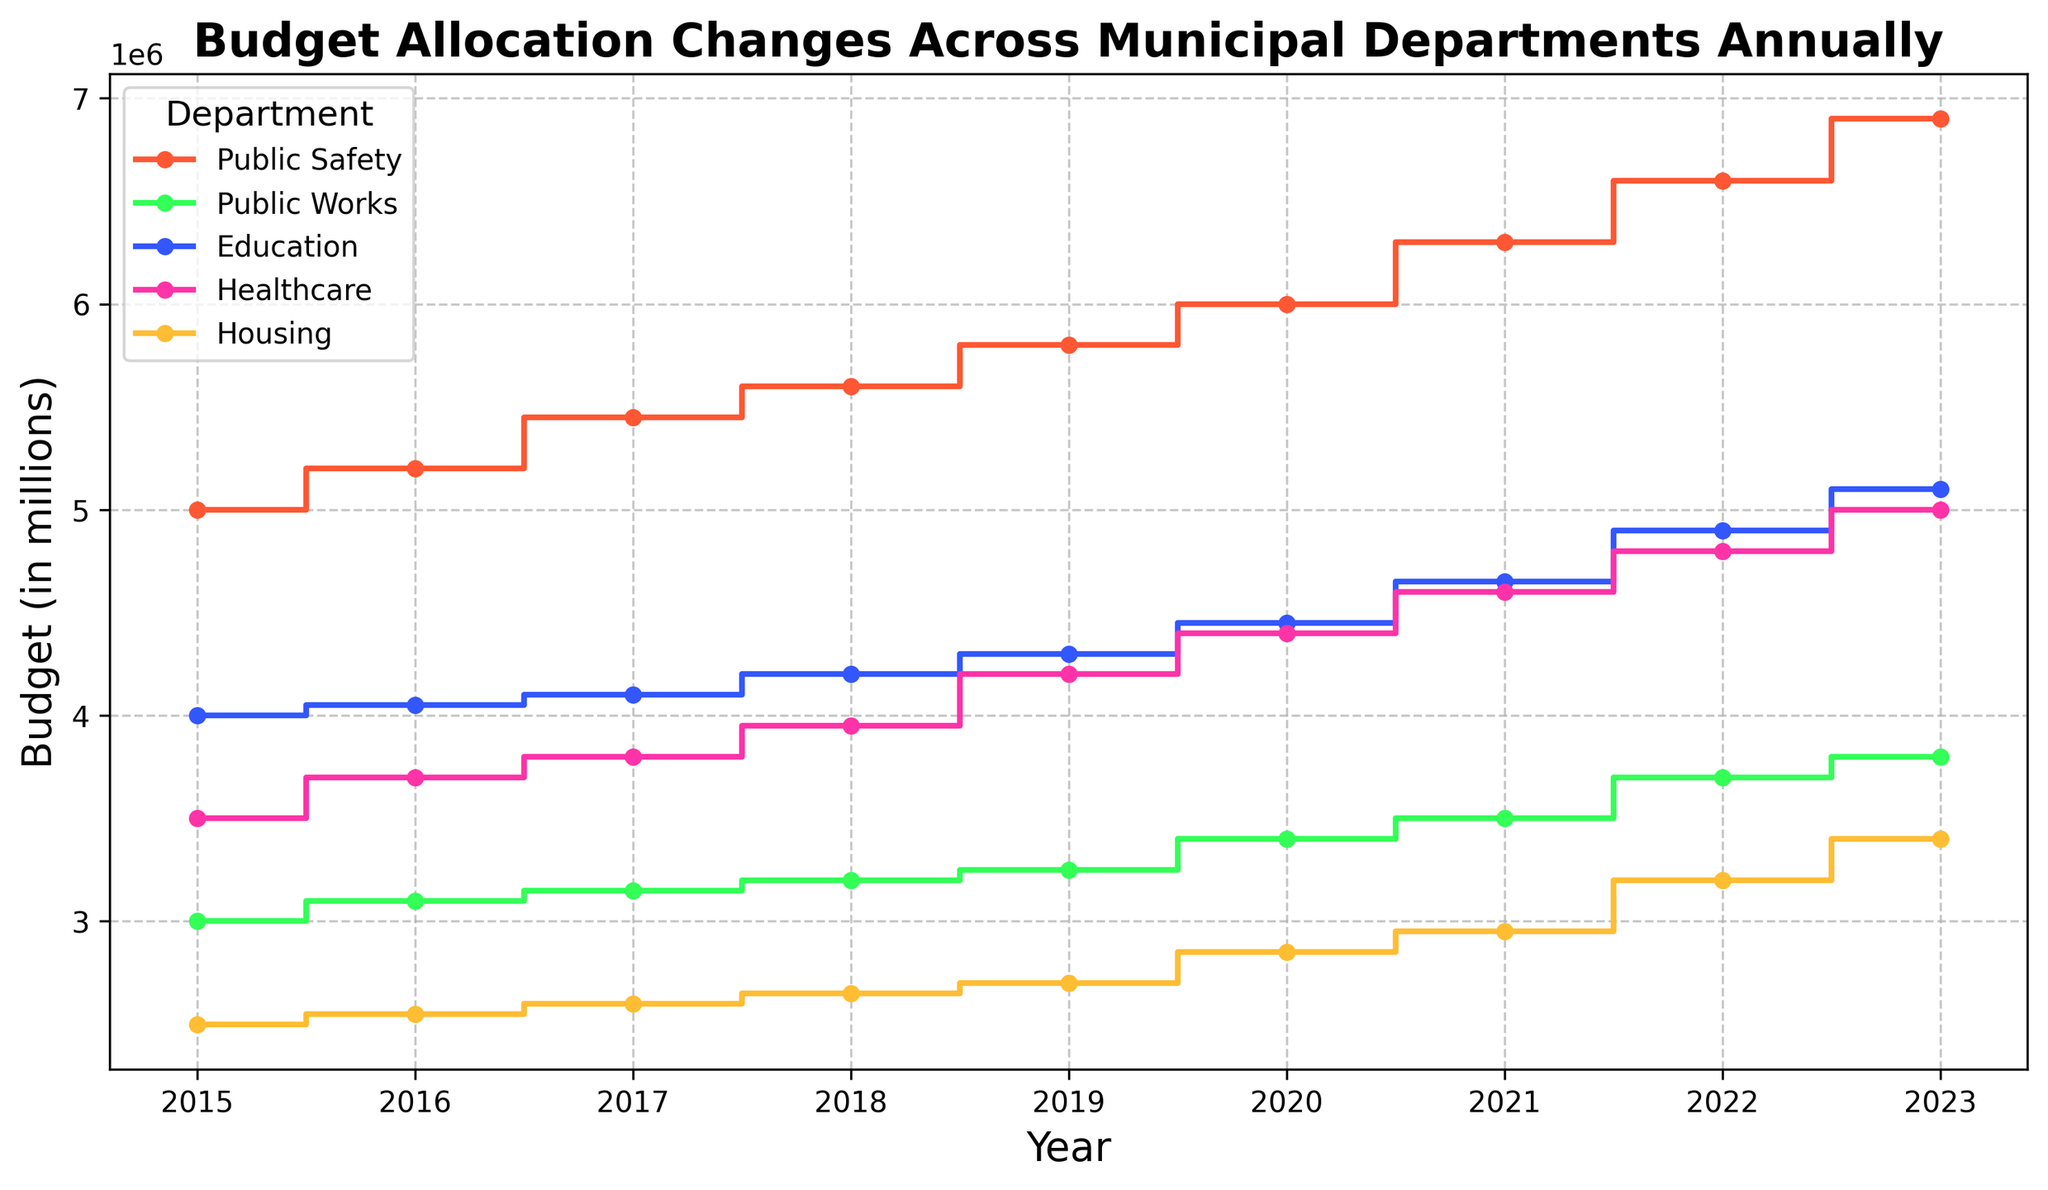What department had the highest budget increase between 2020 and 2021? First, find the budgets for each department in 2020 and 2021. Then, calculate the increase for each department by subtracting the 2020 budget from the 2021 budget. Public Safety: (6300000 - 6000000) = 300000. Public Works: (3500000 - 3400000) = 100000. Education: (4650000 - 4450000) = 200000. Healthcare: (4600000 - 4400000) = 200000. Housing: (2950000 - 2850000) = 100000. Public Safety has the highest increase of 300000
Answer: Public Safety What was the budget for Education in 2022? Look for the Education budget line at the year 2022. The step indicates the budget of 4900000.
Answer: 4900000 Which department had the smallest budget in 2019? Find the budget values for each department in 2019. Public Safety: 5800000, Public Works: 3250000, Education: 4300000, Healthcare: 4200000, Housing: 2700000. The smallest budget is for Housing with 2700000.
Answer: Housing How many years did it take for Housing to reach a budget of 3200000 from 2500000? Find the starting budget (2500000 in 2015) and the target budget (3200000 in 2022). Count the years between 2015 and 2022. It took 7 years.
Answer: 7 years Which two departments had almost a similar budget in 2023? Look at the 2023 budget values: Public Safety: 6900000, Public Works: 3800000, Education: 5100000, Healthcare: 5000000, Housing: 3400000. Healthcare (5000000) and Education (5100000) have close budgets.
Answer: Healthcare and Education In which year did Public Works see the largest budget jump? Compare the year-over-year budget changes for Public Works: 2015-2016 (100000), 2016-2017 (50000), 2017-2018 (50000), 2018-2019 (50000), 2019-2020 (150000), 2020-2021 (100000), 2021-2022 (200000). The largest jump is from 2021 to 2022 with 200000.
Answer: 2021 What's the total budget allocation for Healthcare over the given years? Add the yearly budgets for Healthcare: 3500000 + 3700000 + 3800000 + 3950000 + 4200000 + 4400000 + 4600000 + 4800000 + 5000000 = 37900000.
Answer: 37900000 Which department utilized the blue color in the steps plot? The blue color is visually assigned to Education as per the plot legend.
Answer: Education Did Housing's budget ever exceed 3 million before 2020? Housing budgets: 2015 (2500000), 2016 (2550000), 2017 (2600000), 2018 (2650000), 2019 (2700000). None of these values exceed 3 million before 2020.
Answer: No What is the average yearly budget for Public Safety from 2015 to 2023? Add the yearly budgets for Public Safety and divide by the number of years: (5000000 + 5200000 + 5450000 + 5600000 + 5800000 + 6000000 + 6300000 + 6600000 + 6900000) / 9 = 5877778 (rounded to nearest whole number).
Answer: 5877778 